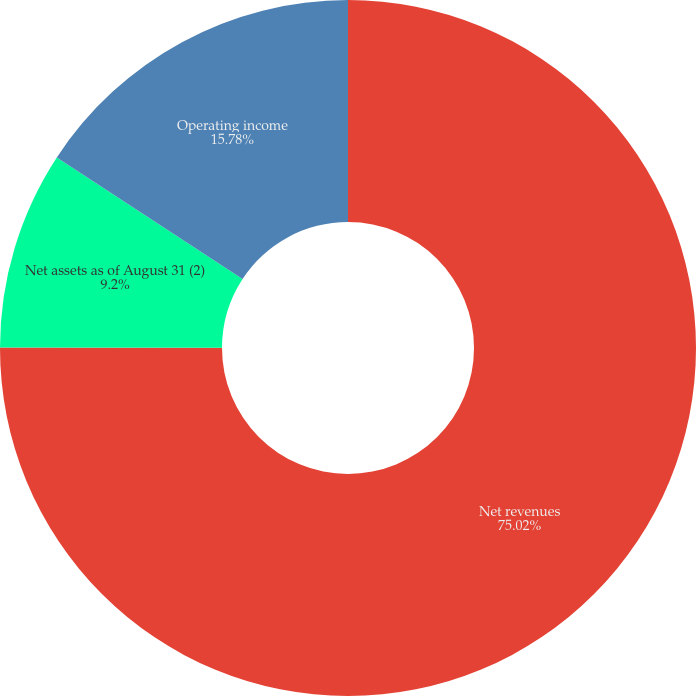Convert chart to OTSL. <chart><loc_0><loc_0><loc_500><loc_500><pie_chart><fcel>Net revenues<fcel>Net assets as of August 31 (2)<fcel>Operating income<nl><fcel>75.03%<fcel>9.2%<fcel>15.78%<nl></chart> 